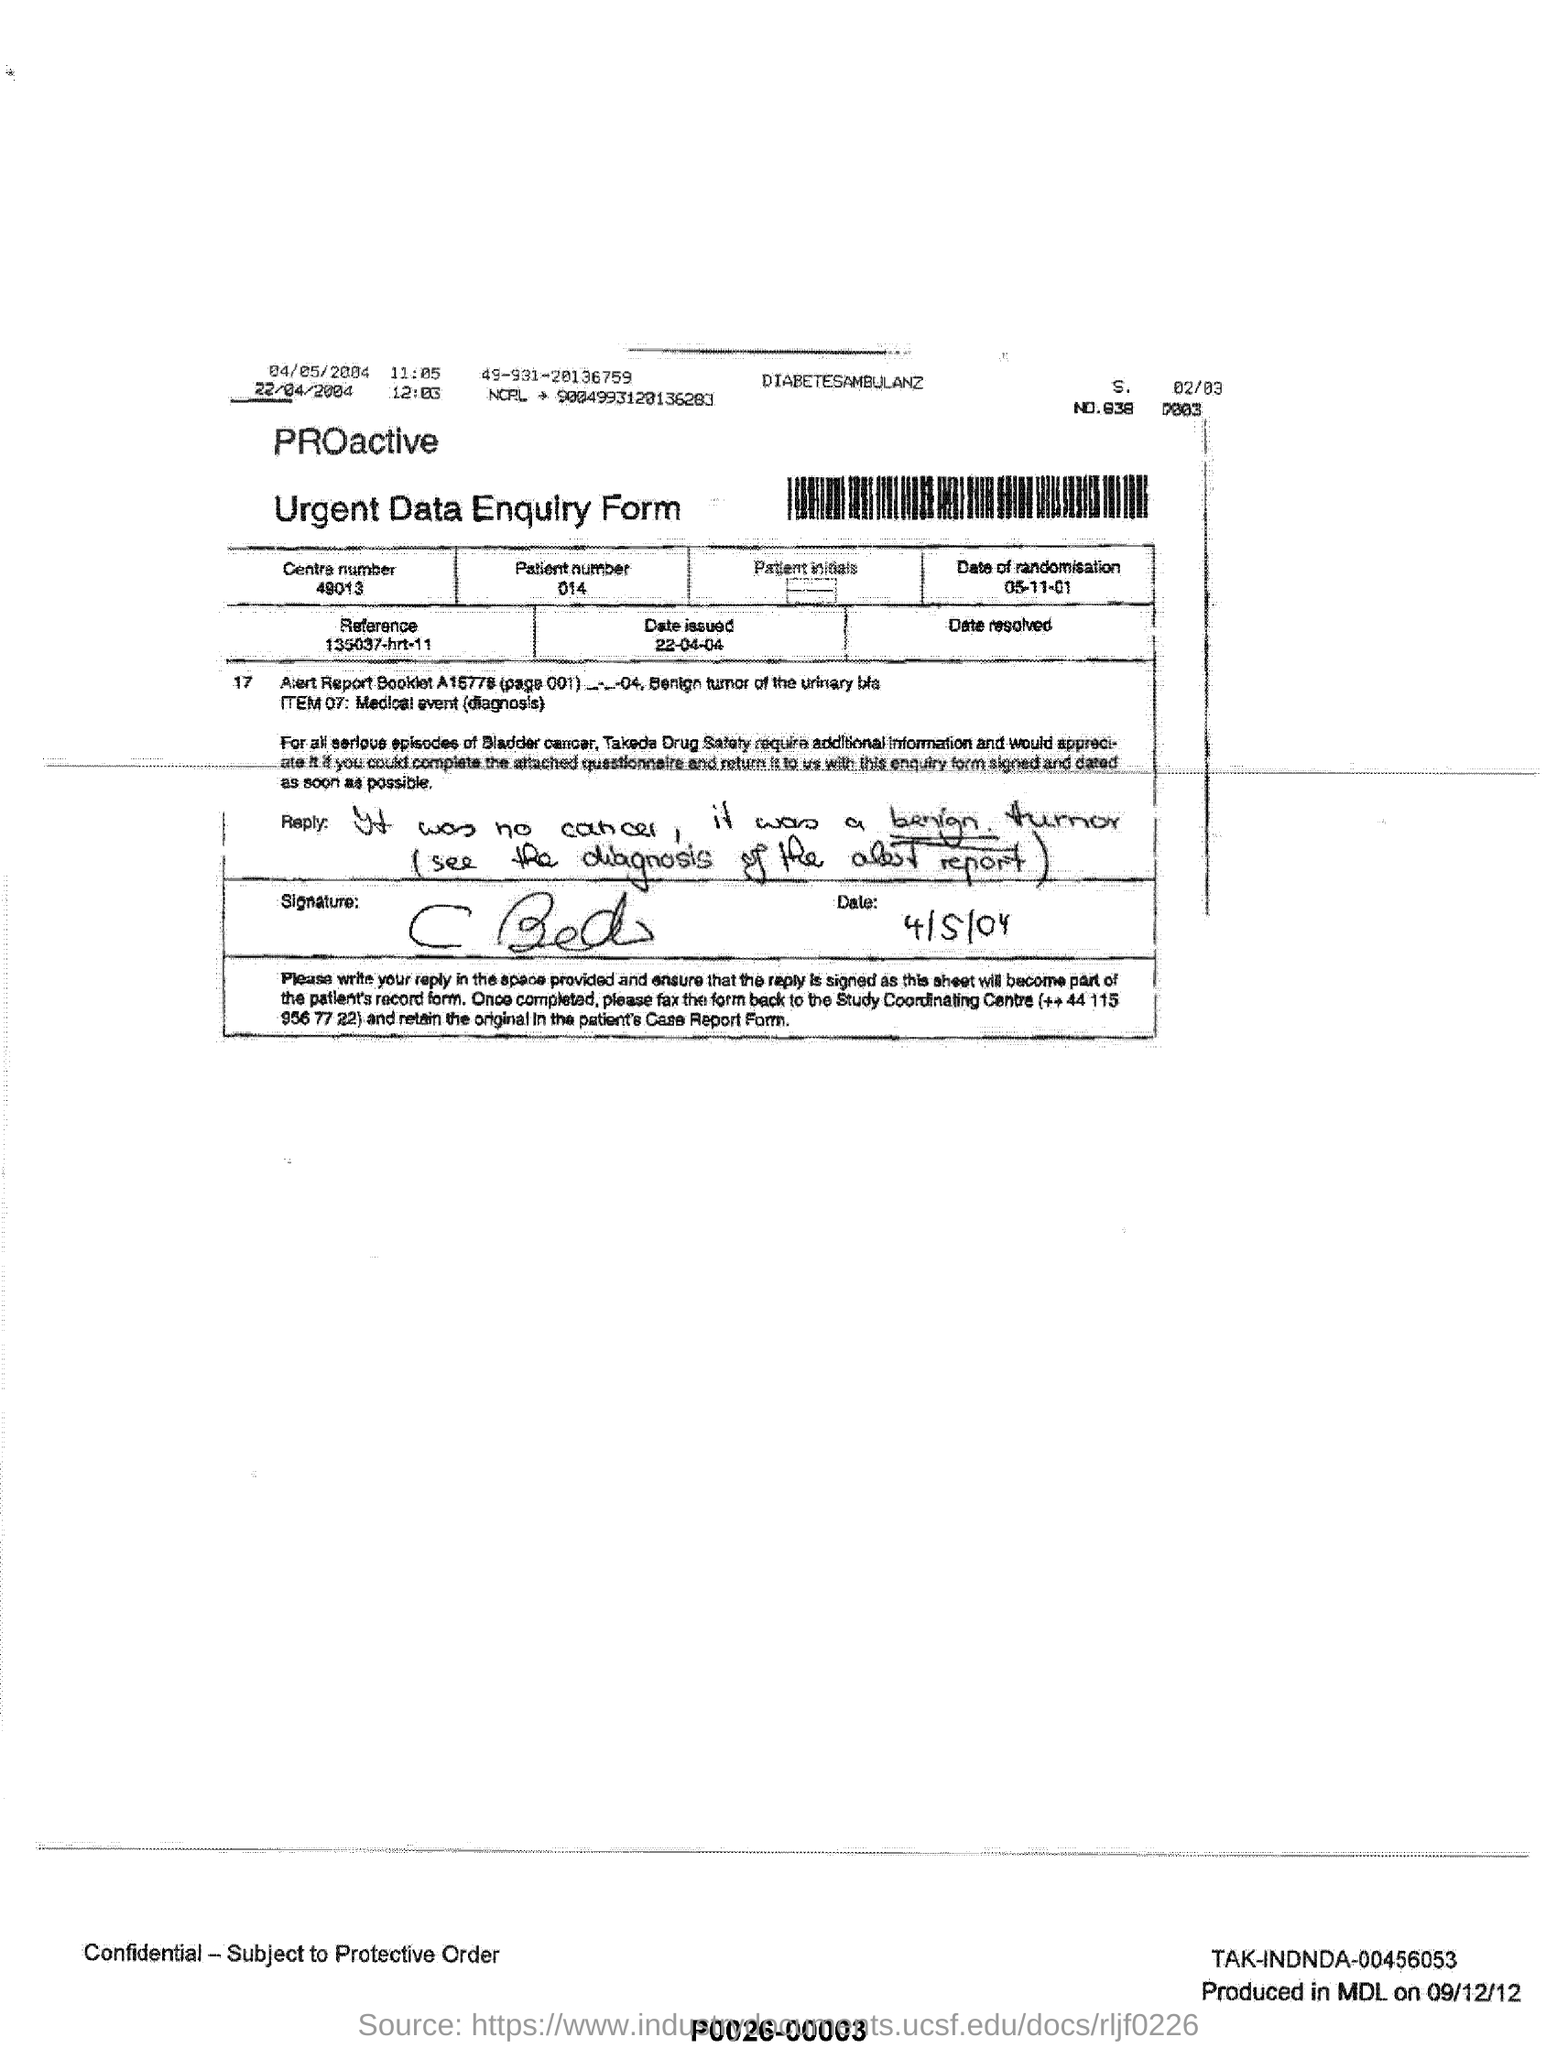What is the date of randomisation?
Offer a very short reply. 05/11/01. What is the patient number?
Offer a terse response. 014. What is the Centre number?
Give a very brief answer. 49013. What is the Reference mentioned here?
Keep it short and to the point. 135037-hrt-11. 